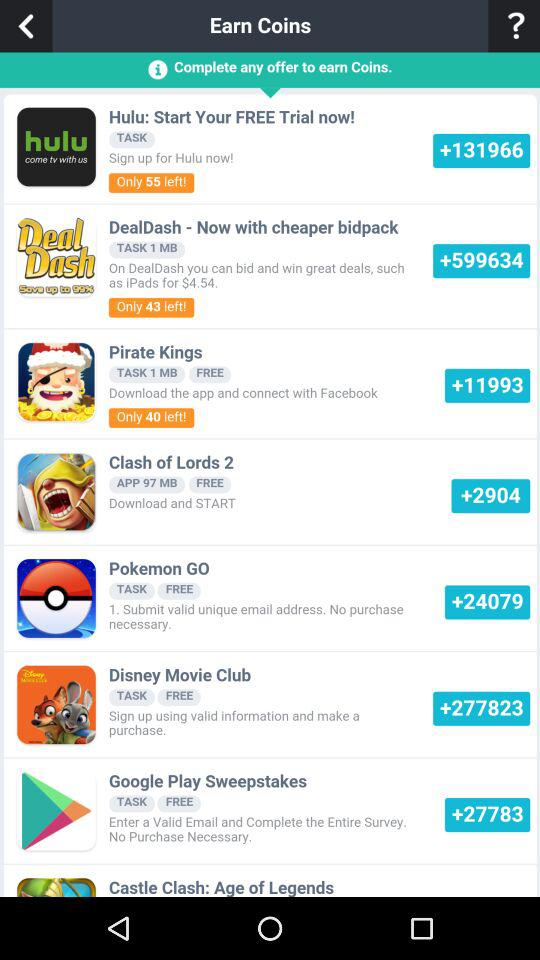Is "Pirate Kings" free or paid? "Pirate Kings" is free. 